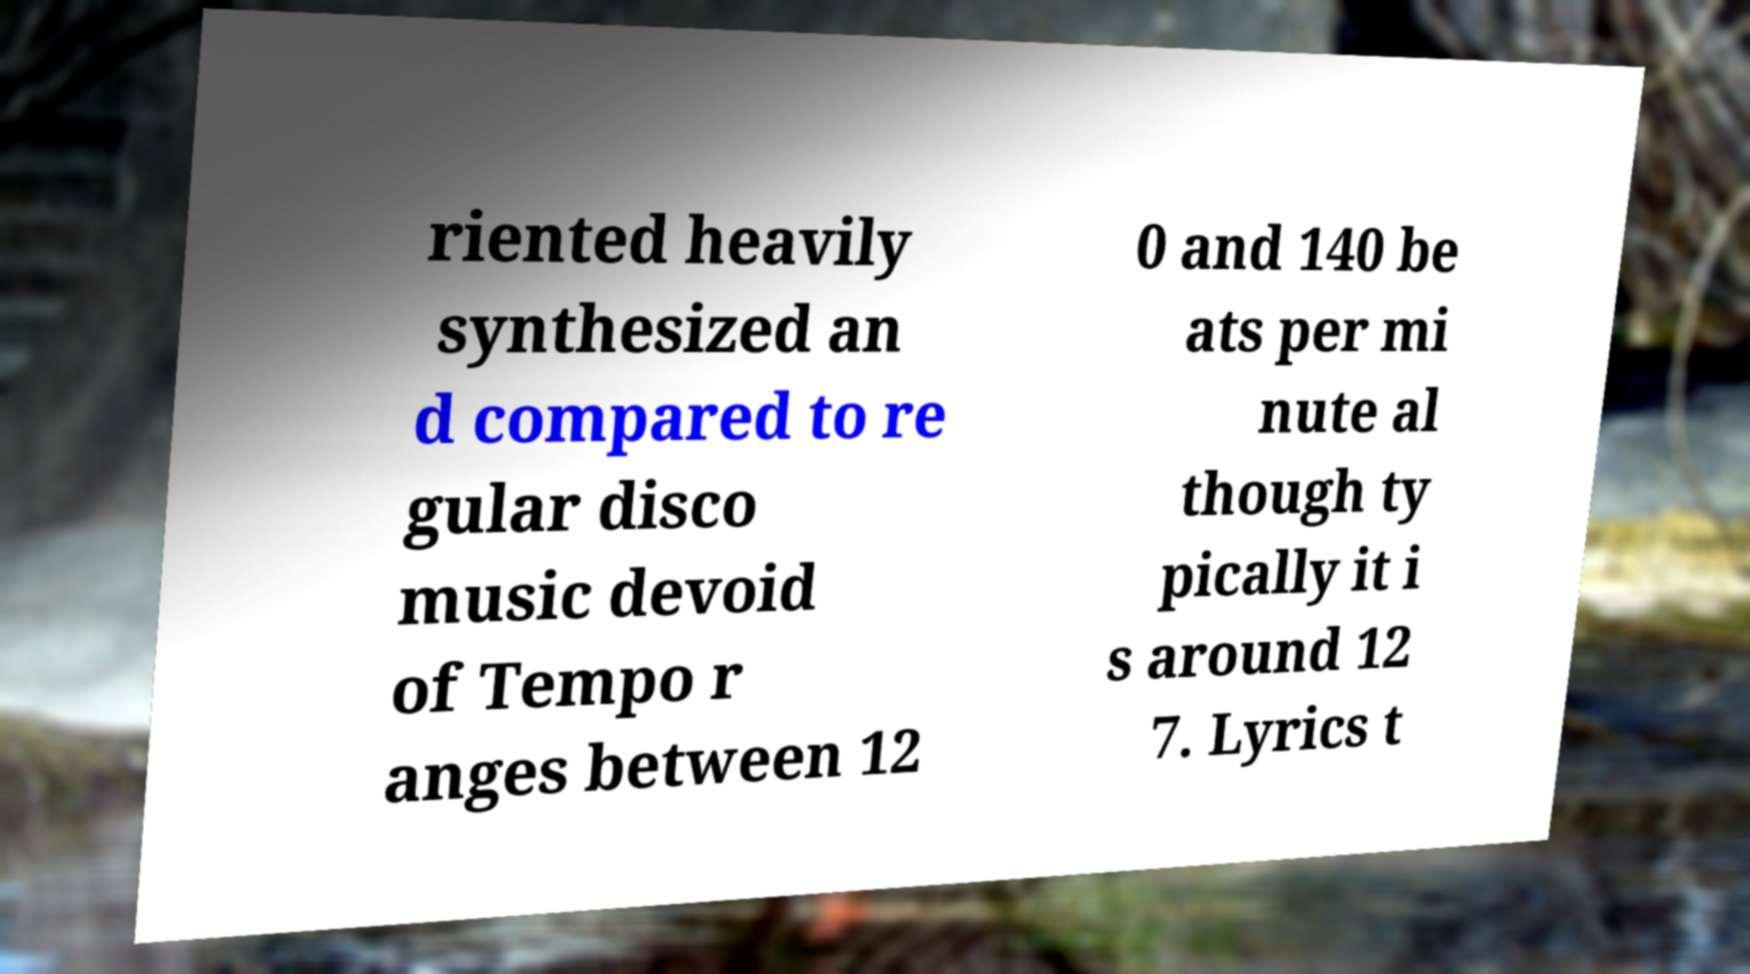I need the written content from this picture converted into text. Can you do that? riented heavily synthesized an d compared to re gular disco music devoid of Tempo r anges between 12 0 and 140 be ats per mi nute al though ty pically it i s around 12 7. Lyrics t 